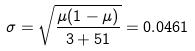<formula> <loc_0><loc_0><loc_500><loc_500>\sigma = \sqrt { \frac { \mu ( 1 - \mu ) } { 3 + 5 1 } } = 0 . 0 4 6 1</formula> 